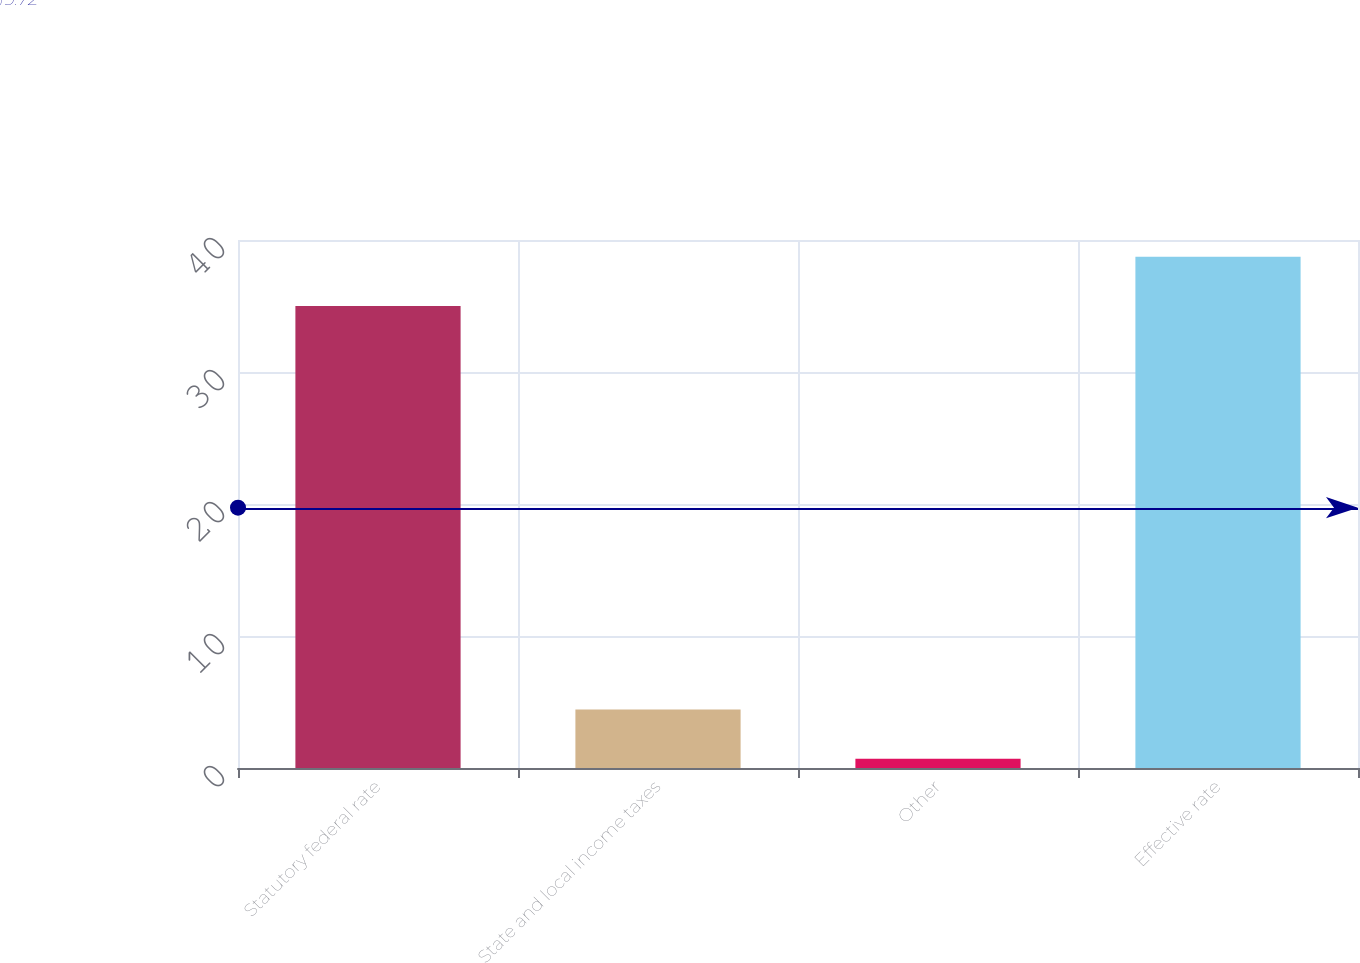<chart> <loc_0><loc_0><loc_500><loc_500><bar_chart><fcel>Statutory federal rate<fcel>State and local income taxes<fcel>Other<fcel>Effective rate<nl><fcel>35<fcel>4.44<fcel>0.7<fcel>38.74<nl></chart> 